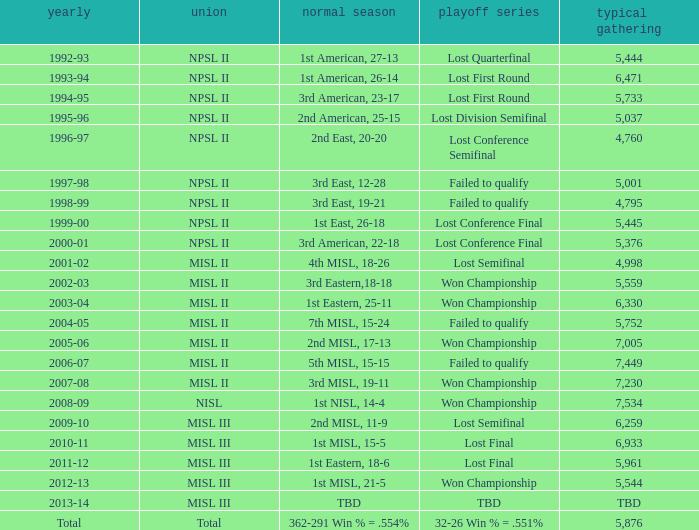When was the year that had an average attendance of 5,445? 1999-00. 